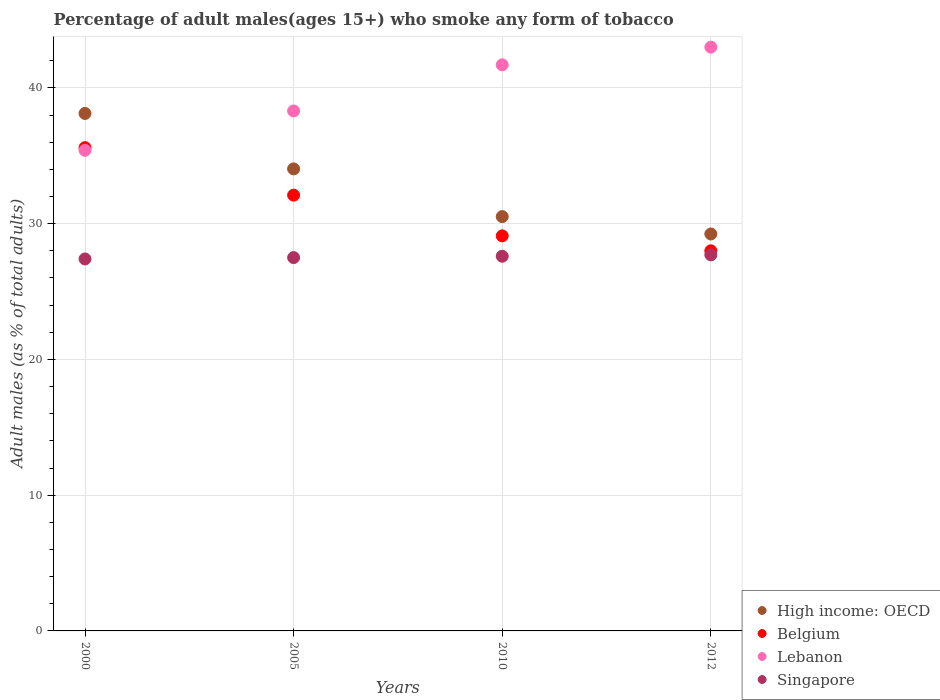What is the percentage of adult males who smoke in Lebanon in 2000?
Provide a succinct answer. 35.4. Across all years, what is the maximum percentage of adult males who smoke in Singapore?
Ensure brevity in your answer.  27.7. Across all years, what is the minimum percentage of adult males who smoke in Lebanon?
Your answer should be compact. 35.4. In which year was the percentage of adult males who smoke in High income: OECD maximum?
Your answer should be compact. 2000. What is the total percentage of adult males who smoke in Lebanon in the graph?
Offer a terse response. 158.4. What is the difference between the percentage of adult males who smoke in Lebanon in 2000 and that in 2012?
Offer a very short reply. -7.6. What is the difference between the percentage of adult males who smoke in Belgium in 2005 and the percentage of adult males who smoke in Lebanon in 2012?
Make the answer very short. -10.9. What is the average percentage of adult males who smoke in Lebanon per year?
Provide a succinct answer. 39.6. In the year 2005, what is the difference between the percentage of adult males who smoke in Lebanon and percentage of adult males who smoke in Belgium?
Keep it short and to the point. 6.2. In how many years, is the percentage of adult males who smoke in Singapore greater than 18 %?
Make the answer very short. 4. What is the ratio of the percentage of adult males who smoke in Singapore in 2010 to that in 2012?
Your answer should be very brief. 1. Is the difference between the percentage of adult males who smoke in Lebanon in 2000 and 2005 greater than the difference between the percentage of adult males who smoke in Belgium in 2000 and 2005?
Your answer should be compact. No. What is the difference between the highest and the second highest percentage of adult males who smoke in Singapore?
Keep it short and to the point. 0.1. What is the difference between the highest and the lowest percentage of adult males who smoke in Singapore?
Your response must be concise. 0.3. What is the difference between two consecutive major ticks on the Y-axis?
Your response must be concise. 10. Are the values on the major ticks of Y-axis written in scientific E-notation?
Keep it short and to the point. No. How many legend labels are there?
Your answer should be compact. 4. How are the legend labels stacked?
Keep it short and to the point. Vertical. What is the title of the graph?
Provide a short and direct response. Percentage of adult males(ages 15+) who smoke any form of tobacco. Does "Ghana" appear as one of the legend labels in the graph?
Provide a succinct answer. No. What is the label or title of the Y-axis?
Your answer should be compact. Adult males (as % of total adults). What is the Adult males (as % of total adults) of High income: OECD in 2000?
Your answer should be very brief. 38.12. What is the Adult males (as % of total adults) of Belgium in 2000?
Your answer should be very brief. 35.6. What is the Adult males (as % of total adults) in Lebanon in 2000?
Your response must be concise. 35.4. What is the Adult males (as % of total adults) in Singapore in 2000?
Provide a short and direct response. 27.4. What is the Adult males (as % of total adults) of High income: OECD in 2005?
Keep it short and to the point. 34.03. What is the Adult males (as % of total adults) of Belgium in 2005?
Provide a succinct answer. 32.1. What is the Adult males (as % of total adults) in Lebanon in 2005?
Provide a short and direct response. 38.3. What is the Adult males (as % of total adults) in High income: OECD in 2010?
Keep it short and to the point. 30.52. What is the Adult males (as % of total adults) of Belgium in 2010?
Offer a terse response. 29.1. What is the Adult males (as % of total adults) of Lebanon in 2010?
Give a very brief answer. 41.7. What is the Adult males (as % of total adults) of Singapore in 2010?
Make the answer very short. 27.6. What is the Adult males (as % of total adults) in High income: OECD in 2012?
Ensure brevity in your answer.  29.24. What is the Adult males (as % of total adults) in Singapore in 2012?
Ensure brevity in your answer.  27.7. Across all years, what is the maximum Adult males (as % of total adults) of High income: OECD?
Provide a succinct answer. 38.12. Across all years, what is the maximum Adult males (as % of total adults) of Belgium?
Provide a short and direct response. 35.6. Across all years, what is the maximum Adult males (as % of total adults) in Lebanon?
Your answer should be very brief. 43. Across all years, what is the maximum Adult males (as % of total adults) of Singapore?
Make the answer very short. 27.7. Across all years, what is the minimum Adult males (as % of total adults) of High income: OECD?
Your answer should be compact. 29.24. Across all years, what is the minimum Adult males (as % of total adults) in Lebanon?
Give a very brief answer. 35.4. Across all years, what is the minimum Adult males (as % of total adults) of Singapore?
Provide a short and direct response. 27.4. What is the total Adult males (as % of total adults) of High income: OECD in the graph?
Keep it short and to the point. 131.91. What is the total Adult males (as % of total adults) in Belgium in the graph?
Provide a short and direct response. 124.8. What is the total Adult males (as % of total adults) of Lebanon in the graph?
Your answer should be compact. 158.4. What is the total Adult males (as % of total adults) of Singapore in the graph?
Give a very brief answer. 110.2. What is the difference between the Adult males (as % of total adults) of High income: OECD in 2000 and that in 2005?
Provide a short and direct response. 4.08. What is the difference between the Adult males (as % of total adults) of Lebanon in 2000 and that in 2005?
Ensure brevity in your answer.  -2.9. What is the difference between the Adult males (as % of total adults) in High income: OECD in 2000 and that in 2010?
Offer a very short reply. 7.6. What is the difference between the Adult males (as % of total adults) in Lebanon in 2000 and that in 2010?
Keep it short and to the point. -6.3. What is the difference between the Adult males (as % of total adults) in High income: OECD in 2000 and that in 2012?
Keep it short and to the point. 8.88. What is the difference between the Adult males (as % of total adults) in Belgium in 2000 and that in 2012?
Your response must be concise. 7.6. What is the difference between the Adult males (as % of total adults) of High income: OECD in 2005 and that in 2010?
Make the answer very short. 3.51. What is the difference between the Adult males (as % of total adults) in Belgium in 2005 and that in 2010?
Provide a succinct answer. 3. What is the difference between the Adult males (as % of total adults) in High income: OECD in 2005 and that in 2012?
Your answer should be compact. 4.79. What is the difference between the Adult males (as % of total adults) of Belgium in 2005 and that in 2012?
Offer a very short reply. 4.1. What is the difference between the Adult males (as % of total adults) in Lebanon in 2005 and that in 2012?
Your response must be concise. -4.7. What is the difference between the Adult males (as % of total adults) of High income: OECD in 2010 and that in 2012?
Keep it short and to the point. 1.28. What is the difference between the Adult males (as % of total adults) of High income: OECD in 2000 and the Adult males (as % of total adults) of Belgium in 2005?
Offer a terse response. 6.02. What is the difference between the Adult males (as % of total adults) of High income: OECD in 2000 and the Adult males (as % of total adults) of Lebanon in 2005?
Keep it short and to the point. -0.18. What is the difference between the Adult males (as % of total adults) in High income: OECD in 2000 and the Adult males (as % of total adults) in Singapore in 2005?
Offer a terse response. 10.62. What is the difference between the Adult males (as % of total adults) in Lebanon in 2000 and the Adult males (as % of total adults) in Singapore in 2005?
Provide a short and direct response. 7.9. What is the difference between the Adult males (as % of total adults) of High income: OECD in 2000 and the Adult males (as % of total adults) of Belgium in 2010?
Keep it short and to the point. 9.02. What is the difference between the Adult males (as % of total adults) in High income: OECD in 2000 and the Adult males (as % of total adults) in Lebanon in 2010?
Offer a very short reply. -3.58. What is the difference between the Adult males (as % of total adults) of High income: OECD in 2000 and the Adult males (as % of total adults) of Singapore in 2010?
Offer a terse response. 10.52. What is the difference between the Adult males (as % of total adults) of Lebanon in 2000 and the Adult males (as % of total adults) of Singapore in 2010?
Offer a terse response. 7.8. What is the difference between the Adult males (as % of total adults) of High income: OECD in 2000 and the Adult males (as % of total adults) of Belgium in 2012?
Provide a short and direct response. 10.12. What is the difference between the Adult males (as % of total adults) in High income: OECD in 2000 and the Adult males (as % of total adults) in Lebanon in 2012?
Offer a terse response. -4.88. What is the difference between the Adult males (as % of total adults) in High income: OECD in 2000 and the Adult males (as % of total adults) in Singapore in 2012?
Your response must be concise. 10.42. What is the difference between the Adult males (as % of total adults) of Belgium in 2000 and the Adult males (as % of total adults) of Singapore in 2012?
Your answer should be very brief. 7.9. What is the difference between the Adult males (as % of total adults) in High income: OECD in 2005 and the Adult males (as % of total adults) in Belgium in 2010?
Offer a very short reply. 4.93. What is the difference between the Adult males (as % of total adults) in High income: OECD in 2005 and the Adult males (as % of total adults) in Lebanon in 2010?
Provide a short and direct response. -7.67. What is the difference between the Adult males (as % of total adults) of High income: OECD in 2005 and the Adult males (as % of total adults) of Singapore in 2010?
Keep it short and to the point. 6.43. What is the difference between the Adult males (as % of total adults) of Belgium in 2005 and the Adult males (as % of total adults) of Lebanon in 2010?
Provide a short and direct response. -9.6. What is the difference between the Adult males (as % of total adults) in Belgium in 2005 and the Adult males (as % of total adults) in Singapore in 2010?
Ensure brevity in your answer.  4.5. What is the difference between the Adult males (as % of total adults) of High income: OECD in 2005 and the Adult males (as % of total adults) of Belgium in 2012?
Give a very brief answer. 6.03. What is the difference between the Adult males (as % of total adults) of High income: OECD in 2005 and the Adult males (as % of total adults) of Lebanon in 2012?
Make the answer very short. -8.97. What is the difference between the Adult males (as % of total adults) in High income: OECD in 2005 and the Adult males (as % of total adults) in Singapore in 2012?
Provide a short and direct response. 6.33. What is the difference between the Adult males (as % of total adults) of Lebanon in 2005 and the Adult males (as % of total adults) of Singapore in 2012?
Provide a short and direct response. 10.6. What is the difference between the Adult males (as % of total adults) of High income: OECD in 2010 and the Adult males (as % of total adults) of Belgium in 2012?
Offer a very short reply. 2.52. What is the difference between the Adult males (as % of total adults) of High income: OECD in 2010 and the Adult males (as % of total adults) of Lebanon in 2012?
Your answer should be compact. -12.48. What is the difference between the Adult males (as % of total adults) in High income: OECD in 2010 and the Adult males (as % of total adults) in Singapore in 2012?
Provide a succinct answer. 2.82. What is the difference between the Adult males (as % of total adults) in Lebanon in 2010 and the Adult males (as % of total adults) in Singapore in 2012?
Provide a succinct answer. 14. What is the average Adult males (as % of total adults) in High income: OECD per year?
Keep it short and to the point. 32.98. What is the average Adult males (as % of total adults) in Belgium per year?
Offer a very short reply. 31.2. What is the average Adult males (as % of total adults) in Lebanon per year?
Offer a very short reply. 39.6. What is the average Adult males (as % of total adults) of Singapore per year?
Make the answer very short. 27.55. In the year 2000, what is the difference between the Adult males (as % of total adults) in High income: OECD and Adult males (as % of total adults) in Belgium?
Ensure brevity in your answer.  2.52. In the year 2000, what is the difference between the Adult males (as % of total adults) of High income: OECD and Adult males (as % of total adults) of Lebanon?
Offer a very short reply. 2.72. In the year 2000, what is the difference between the Adult males (as % of total adults) in High income: OECD and Adult males (as % of total adults) in Singapore?
Offer a very short reply. 10.72. In the year 2000, what is the difference between the Adult males (as % of total adults) of Belgium and Adult males (as % of total adults) of Lebanon?
Keep it short and to the point. 0.2. In the year 2000, what is the difference between the Adult males (as % of total adults) in Lebanon and Adult males (as % of total adults) in Singapore?
Keep it short and to the point. 8. In the year 2005, what is the difference between the Adult males (as % of total adults) of High income: OECD and Adult males (as % of total adults) of Belgium?
Offer a terse response. 1.93. In the year 2005, what is the difference between the Adult males (as % of total adults) in High income: OECD and Adult males (as % of total adults) in Lebanon?
Keep it short and to the point. -4.27. In the year 2005, what is the difference between the Adult males (as % of total adults) of High income: OECD and Adult males (as % of total adults) of Singapore?
Offer a very short reply. 6.53. In the year 2005, what is the difference between the Adult males (as % of total adults) of Belgium and Adult males (as % of total adults) of Singapore?
Your response must be concise. 4.6. In the year 2010, what is the difference between the Adult males (as % of total adults) in High income: OECD and Adult males (as % of total adults) in Belgium?
Your response must be concise. 1.42. In the year 2010, what is the difference between the Adult males (as % of total adults) of High income: OECD and Adult males (as % of total adults) of Lebanon?
Give a very brief answer. -11.18. In the year 2010, what is the difference between the Adult males (as % of total adults) in High income: OECD and Adult males (as % of total adults) in Singapore?
Ensure brevity in your answer.  2.92. In the year 2010, what is the difference between the Adult males (as % of total adults) in Belgium and Adult males (as % of total adults) in Lebanon?
Keep it short and to the point. -12.6. In the year 2010, what is the difference between the Adult males (as % of total adults) in Belgium and Adult males (as % of total adults) in Singapore?
Your answer should be compact. 1.5. In the year 2012, what is the difference between the Adult males (as % of total adults) in High income: OECD and Adult males (as % of total adults) in Belgium?
Your response must be concise. 1.24. In the year 2012, what is the difference between the Adult males (as % of total adults) in High income: OECD and Adult males (as % of total adults) in Lebanon?
Your response must be concise. -13.76. In the year 2012, what is the difference between the Adult males (as % of total adults) in High income: OECD and Adult males (as % of total adults) in Singapore?
Offer a terse response. 1.54. In the year 2012, what is the difference between the Adult males (as % of total adults) of Belgium and Adult males (as % of total adults) of Singapore?
Your answer should be compact. 0.3. In the year 2012, what is the difference between the Adult males (as % of total adults) of Lebanon and Adult males (as % of total adults) of Singapore?
Keep it short and to the point. 15.3. What is the ratio of the Adult males (as % of total adults) of High income: OECD in 2000 to that in 2005?
Ensure brevity in your answer.  1.12. What is the ratio of the Adult males (as % of total adults) in Belgium in 2000 to that in 2005?
Ensure brevity in your answer.  1.11. What is the ratio of the Adult males (as % of total adults) of Lebanon in 2000 to that in 2005?
Your answer should be very brief. 0.92. What is the ratio of the Adult males (as % of total adults) in Singapore in 2000 to that in 2005?
Offer a very short reply. 1. What is the ratio of the Adult males (as % of total adults) of High income: OECD in 2000 to that in 2010?
Your answer should be compact. 1.25. What is the ratio of the Adult males (as % of total adults) in Belgium in 2000 to that in 2010?
Make the answer very short. 1.22. What is the ratio of the Adult males (as % of total adults) in Lebanon in 2000 to that in 2010?
Offer a terse response. 0.85. What is the ratio of the Adult males (as % of total adults) in Singapore in 2000 to that in 2010?
Your answer should be compact. 0.99. What is the ratio of the Adult males (as % of total adults) of High income: OECD in 2000 to that in 2012?
Ensure brevity in your answer.  1.3. What is the ratio of the Adult males (as % of total adults) of Belgium in 2000 to that in 2012?
Offer a very short reply. 1.27. What is the ratio of the Adult males (as % of total adults) of Lebanon in 2000 to that in 2012?
Offer a terse response. 0.82. What is the ratio of the Adult males (as % of total adults) in High income: OECD in 2005 to that in 2010?
Offer a very short reply. 1.12. What is the ratio of the Adult males (as % of total adults) in Belgium in 2005 to that in 2010?
Provide a succinct answer. 1.1. What is the ratio of the Adult males (as % of total adults) of Lebanon in 2005 to that in 2010?
Provide a succinct answer. 0.92. What is the ratio of the Adult males (as % of total adults) of High income: OECD in 2005 to that in 2012?
Keep it short and to the point. 1.16. What is the ratio of the Adult males (as % of total adults) in Belgium in 2005 to that in 2012?
Your answer should be very brief. 1.15. What is the ratio of the Adult males (as % of total adults) of Lebanon in 2005 to that in 2012?
Ensure brevity in your answer.  0.89. What is the ratio of the Adult males (as % of total adults) in High income: OECD in 2010 to that in 2012?
Ensure brevity in your answer.  1.04. What is the ratio of the Adult males (as % of total adults) in Belgium in 2010 to that in 2012?
Provide a succinct answer. 1.04. What is the ratio of the Adult males (as % of total adults) of Lebanon in 2010 to that in 2012?
Make the answer very short. 0.97. What is the ratio of the Adult males (as % of total adults) in Singapore in 2010 to that in 2012?
Your answer should be compact. 1. What is the difference between the highest and the second highest Adult males (as % of total adults) in High income: OECD?
Your answer should be compact. 4.08. What is the difference between the highest and the second highest Adult males (as % of total adults) in Belgium?
Make the answer very short. 3.5. What is the difference between the highest and the lowest Adult males (as % of total adults) of High income: OECD?
Your answer should be compact. 8.88. What is the difference between the highest and the lowest Adult males (as % of total adults) in Belgium?
Make the answer very short. 7.6. What is the difference between the highest and the lowest Adult males (as % of total adults) in Singapore?
Ensure brevity in your answer.  0.3. 